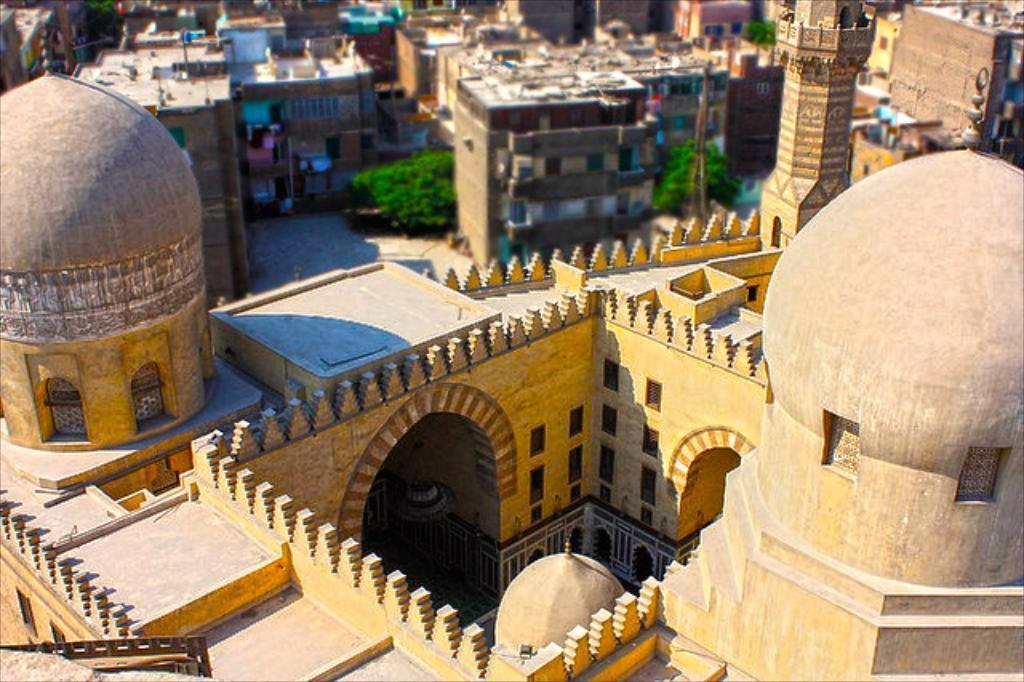Describe this image in one or two sentences. In this image I can see many buildings and trees on the ground. 